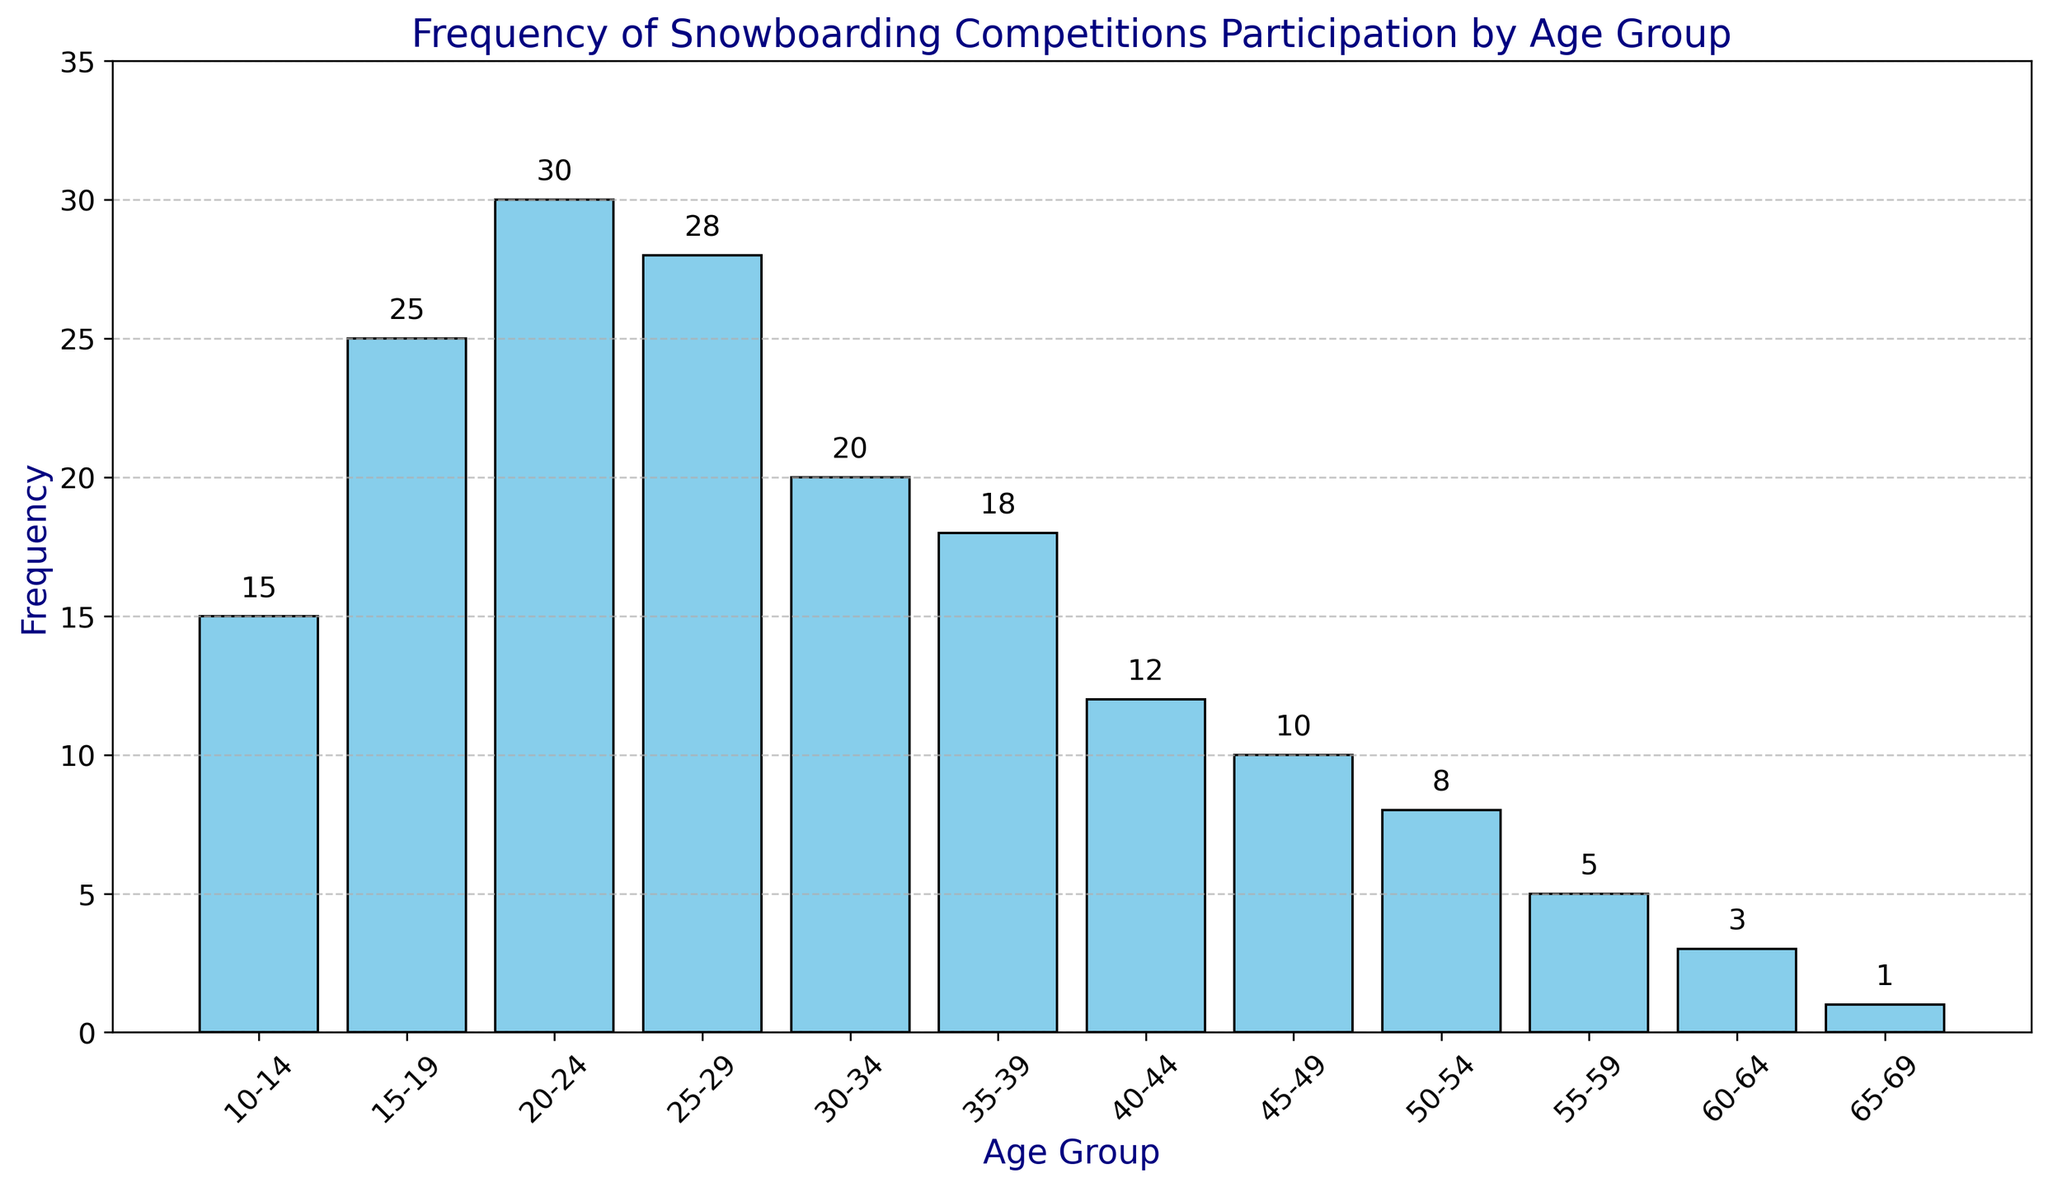What's the most frequent age group for snowboarding competitions? The tallest bar in the histogram represents the age group 20-24, indicating the highest frequency of participation.
Answer: 20-24 Which age group has the lowest participation in snowboarding competitions? The shortest bar represents the age group 65-69, indicating the lowest frequency of participation.
Answer: 65-69 How many age groups have a frequency of 20 or higher? Age groups 15-19, 20-24, 25-29, and 30-34 have frequencies of 20 or higher. This totals four age groups.
Answer: 4 What is the difference in participation frequency between the age groups 20-24 and 40-44? The frequency for 20-24 is 30 and for 40-44 is 12. The difference is 30 - 12 = 18.
Answer: 18 What's the average frequency of participation for the age groups from 10-14 to 25-29? The frequencies are 15, 25, 30, and 28. Sum them: 15 + 25 + 30 + 28 = 98. There are 4 age groups, so the average is 98 / 4 = 24.5.
Answer: 24.5 How does the participation frequency of the age group 35-39 compare to that of 30-34? The frequency for 35-39 is 18, while for 30-34 it is 20. Thus, 35-39 has a lower participation frequency than 30-34 by 2.
Answer: Lower by 2 Calculate the total participation for age groups under 30. The frequencies are 15 (10-14), 25 (15-19), 30 (20-24), and 28 (25-29). Sum them: 15 + 25 + 30 + 28 = 98.
Answer: 98 Which age group between 45-49 and 50-54 has a higher participation frequency? The frequency for 45-49 is 10 and for 50-54 is 8. Thus, 45-49 has a higher participation frequency.
Answer: 45-49 What is the combined frequency of participation for the oldest two age groups? The frequencies for 60-64 and 65-69 are 3 and 1 respectively. Sum them: 3 + 1 = 4.
Answer: 4 Is there an age group with exactly 5 participants? If so, what is it? The age group 55-59 has a frequency of exactly 5 participants.
Answer: 55-59 